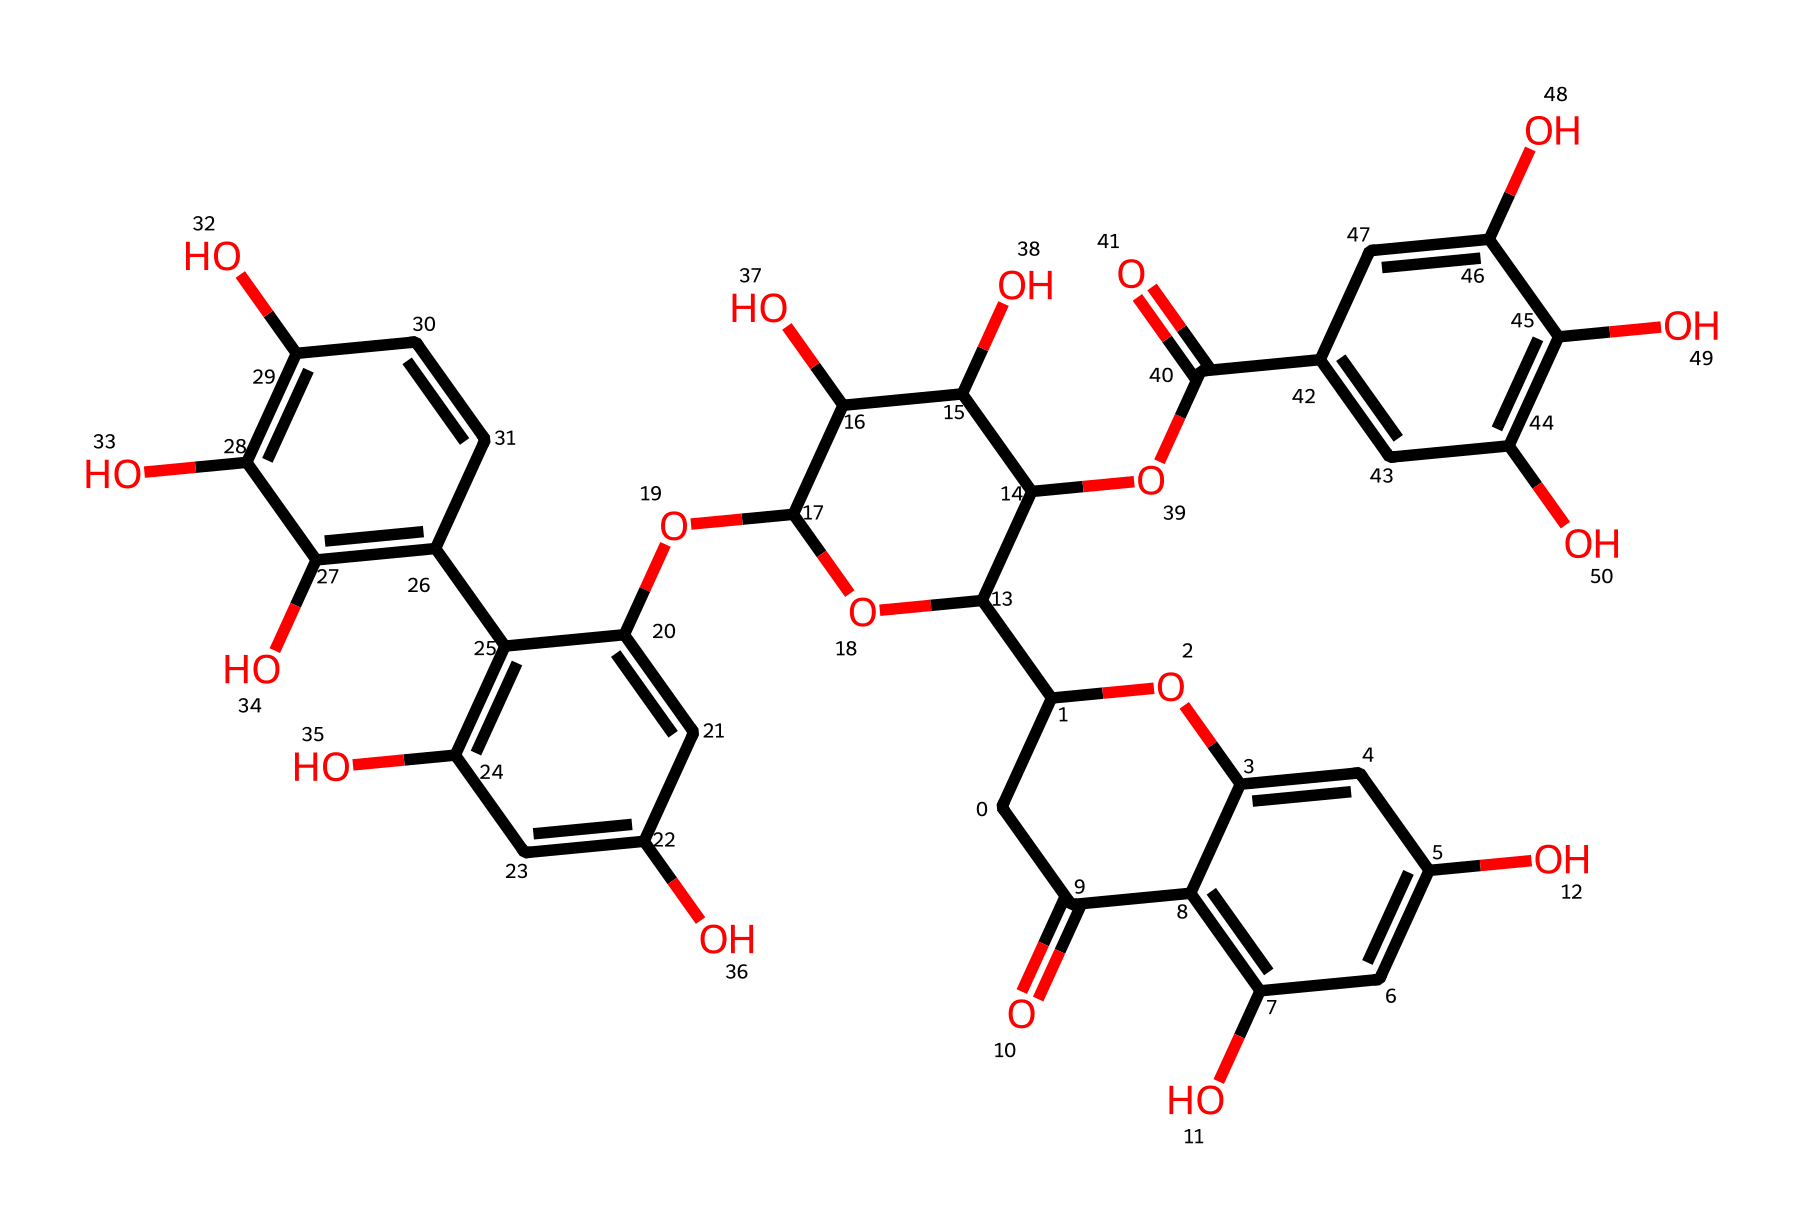What is the molecular formula of tannic acid? The molecular formula can be derived from counting all the carbon (C), hydrogen (H), and oxygen (O) atoms in the SMILES representation. The structure contains 21 carbon atoms, 20 hydrogen atoms, and 10 oxygen atoms. Thus, the molecular formula is C21H20O10.
Answer: C21H20O10 How many hydroxyl groups are present in tannic acid? The hydroxyl groups (-OH) can be identified in the structure, typically indicated by the presence of oxygen bonded to hydrogen. In the given structure, there are 10 hydroxyl groups present as indicated by the patterns of C and O atoms in the SMILES.
Answer: 10 Which part of the structure reveals its acidic nature? The presence of carboxyl groups (-COOH) or phenolic hydroxyl groups indicates acidity. In the structure, these groups can be identified through the arrangement of carbon and oxygen atoms, specifically noting the -OC(=O) structure, which suggests a functional group known for its acidity.
Answer: carboxyl group What is the total number of aromatic rings in tannic acid? Aromatic rings can be identified in the structure by looking for benzene-like patterns—a cyclic structure with alternating double bonds. Upon examining the SMILES, there are four distinct aromatic rings visible in the chemical structure.
Answer: 4 Does tannic acid contain any functional groups that can form hydrogen bonds? The presence of hydroxyl (-OH) and carboxyl (-COOH) groups indicates the potential for hydrogen bond formation. As seen in the structure, these functional groups are present and can actively participate in hydrogen bonding, thus contributing to the solubility and reactivity of tannic acid.
Answer: yes 